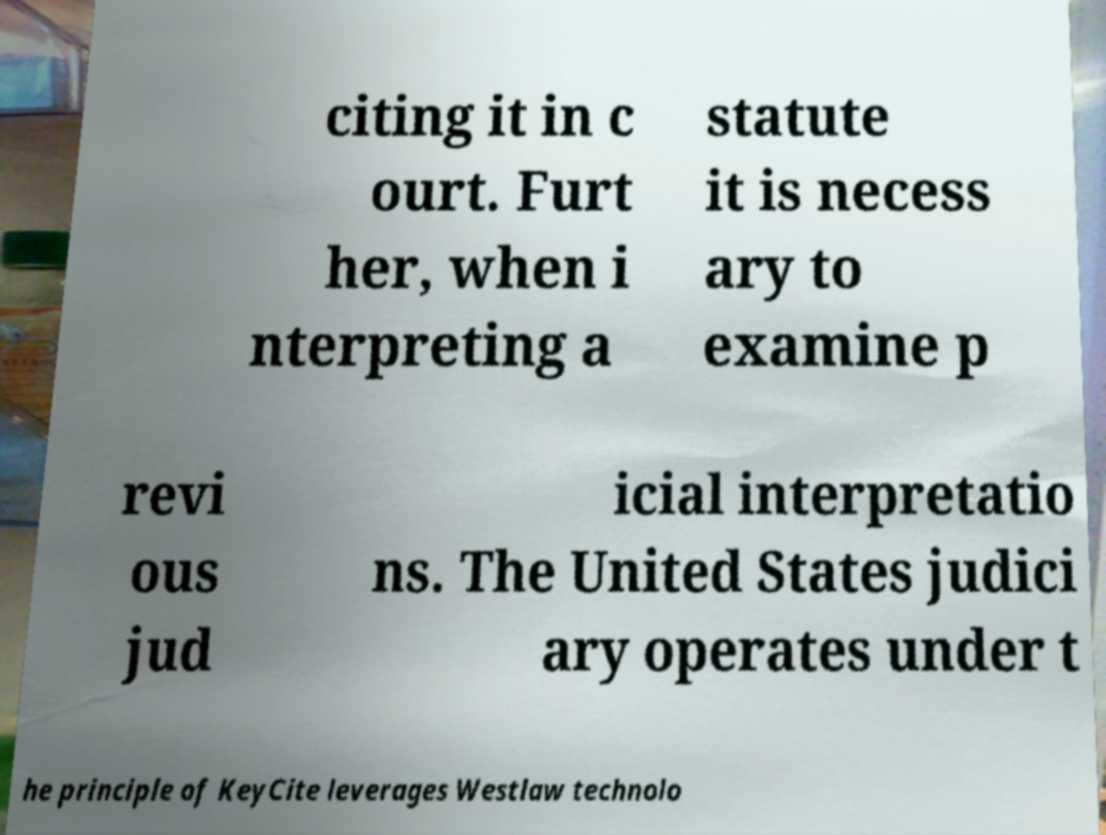Can you accurately transcribe the text from the provided image for me? citing it in c ourt. Furt her, when i nterpreting a statute it is necess ary to examine p revi ous jud icial interpretatio ns. The United States judici ary operates under t he principle of KeyCite leverages Westlaw technolo 